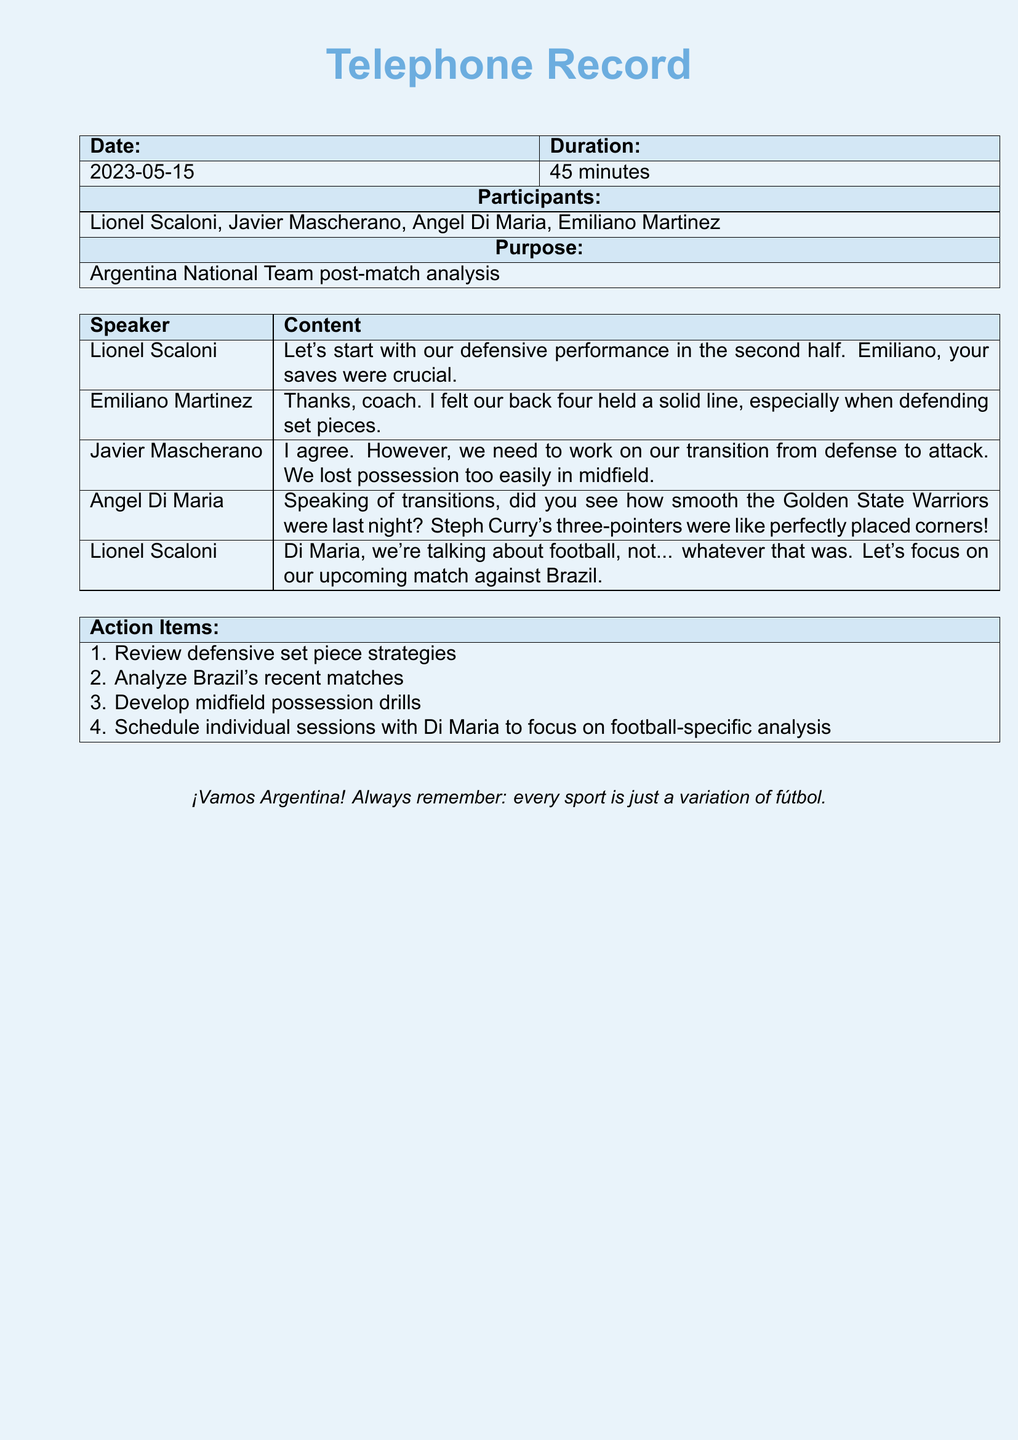What is the date of the telephone record? The date of the telephone record is explicitly mentioned in the document under the date section.
Answer: 2023-05-15 Who is one of the participants in the call? Participants are listed in the document, with each name appearing in the "Participants" section.
Answer: Javier Mascherano What is the total duration of the call? The total duration is specified in the document, giving clear information about the length of the call.
Answer: 45 minutes What action item involves Brazil? The action items are listed clearly, with one of them specifically mentioning analysis of Brazil's matches.
Answer: Analyze Brazil's recent matches Which sport does Di Maria mistakenly reference during the call? The document includes a section of dialogue where Di Maria mentions another sport instead of football.
Answer: Basketball What was Scaloni's focus for the discussion? The purpose of the discussion is stated in the document, which outlines the main focus regarding the national team.
Answer: Defensive performance What did Di Maria compare to football corners? Di Maria made a comparison in his dialogue that relates to a specific sports action, which is documented in the call record.
Answer: Steph Curry's three-pointers What is one of the individual session goals? The action items section details specific goals, including focusing on individual sessions with a participant.
Answer: Focus on football-specific analysis 